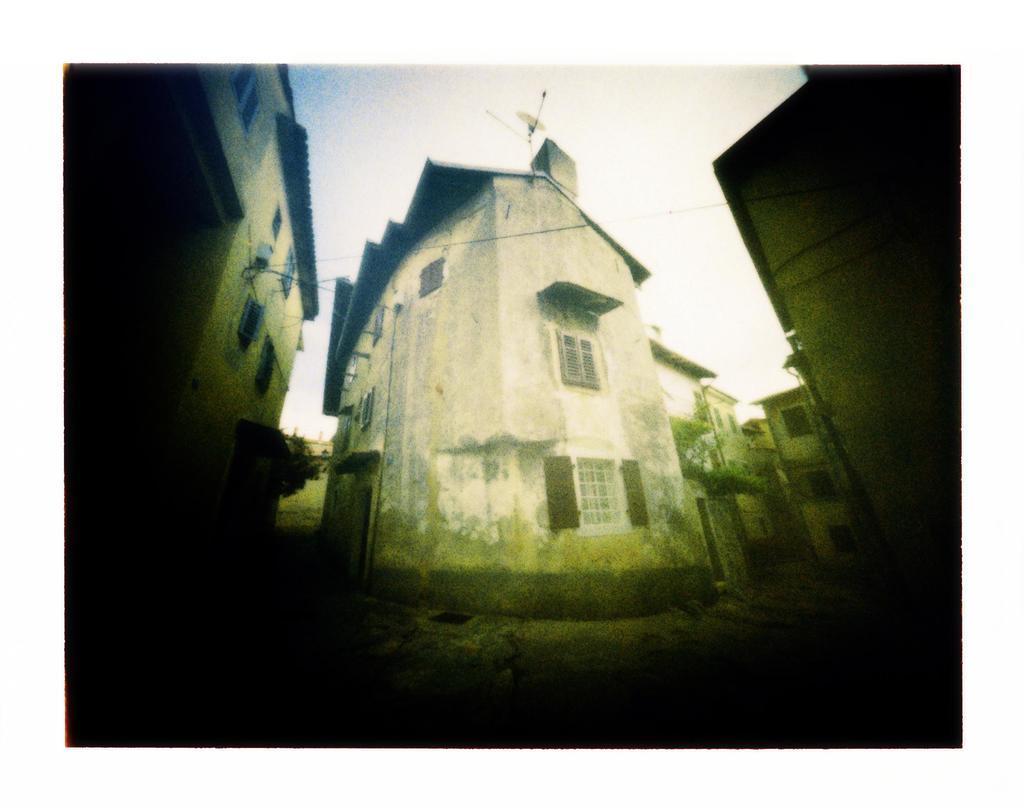Can you describe this image briefly? In this picture there is a small white color house in the in the middle of the image. On both the side there are more houses. 